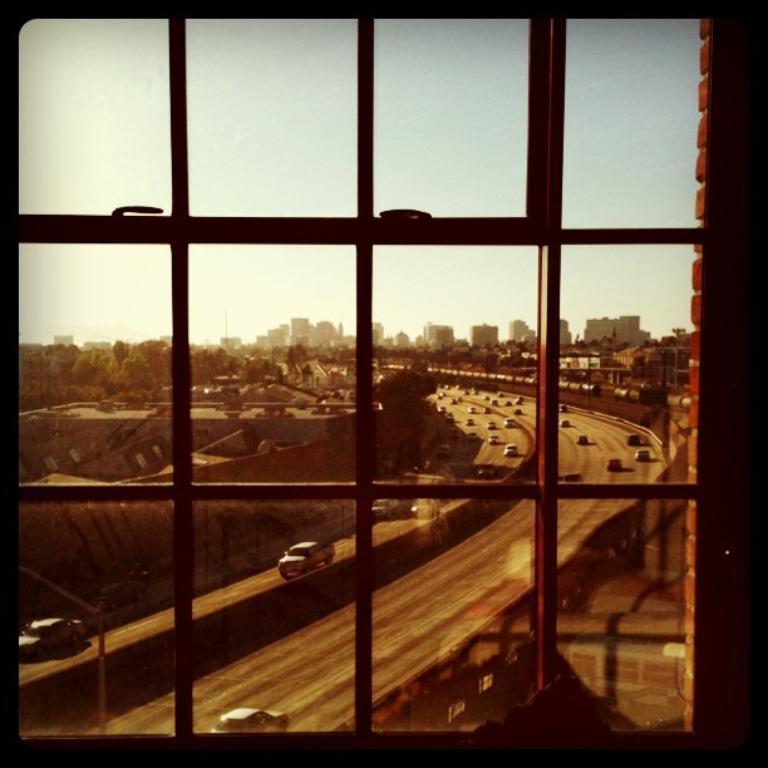Please provide a concise description of this image. In this picture I can see a window, there are vehicles on the road, there are buildings, trees, and in the background there is the sky. 